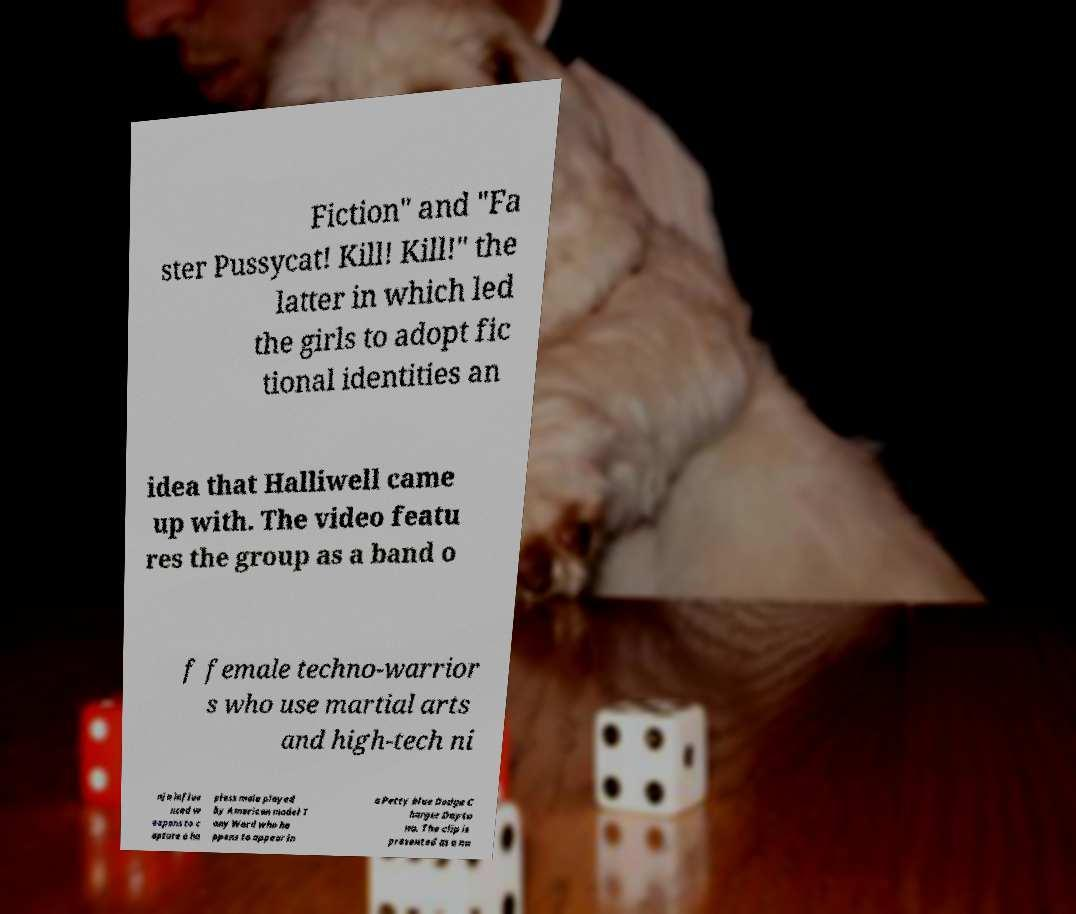Please read and relay the text visible in this image. What does it say? Fiction" and "Fa ster Pussycat! Kill! Kill!" the latter in which led the girls to adopt fic tional identities an idea that Halliwell came up with. The video featu res the group as a band o f female techno-warrior s who use martial arts and high-tech ni nja influe nced w eapons to c apture a ha pless male played by American model T ony Ward who ha ppens to appear in a Petty blue Dodge C harger Dayto na. The clip is presented as a na 